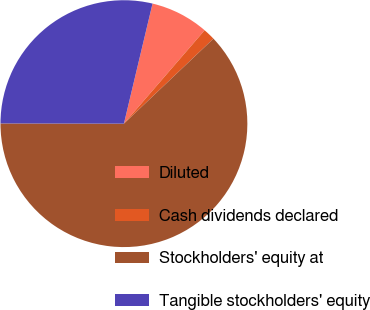<chart> <loc_0><loc_0><loc_500><loc_500><pie_chart><fcel>Diluted<fcel>Cash dividends declared<fcel>Stockholders' equity at<fcel>Tangible stockholders' equity<nl><fcel>7.62%<fcel>1.57%<fcel>62.12%<fcel>28.7%<nl></chart> 